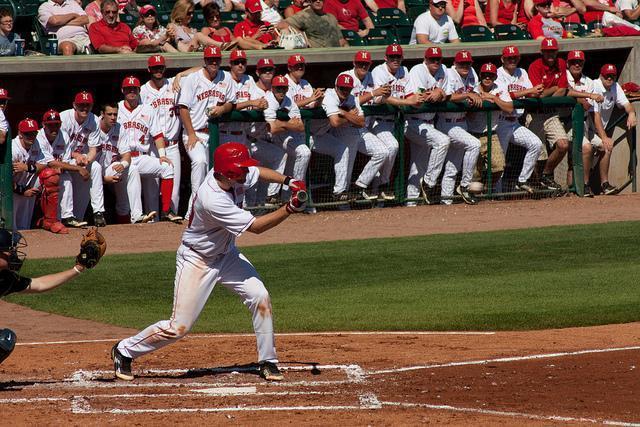How many people are there?
Give a very brief answer. 10. 